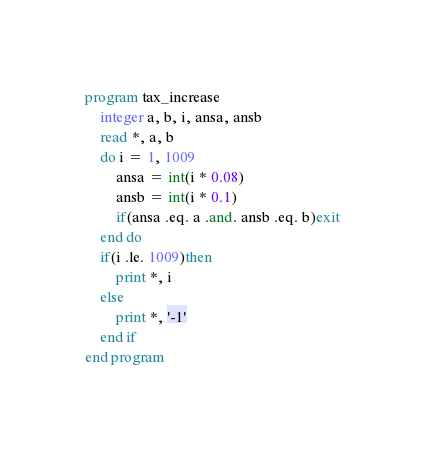Convert code to text. <code><loc_0><loc_0><loc_500><loc_500><_FORTRAN_>program tax_increase
    integer a, b, i, ansa, ansb
    read *, a, b
    do i = 1, 1009
        ansa = int(i * 0.08)
        ansb = int(i * 0.1)
        if(ansa .eq. a .and. ansb .eq. b)exit
    end do
    if(i .le. 1009)then
        print *, i
    else
        print *, '-1'
    end if
end program</code> 